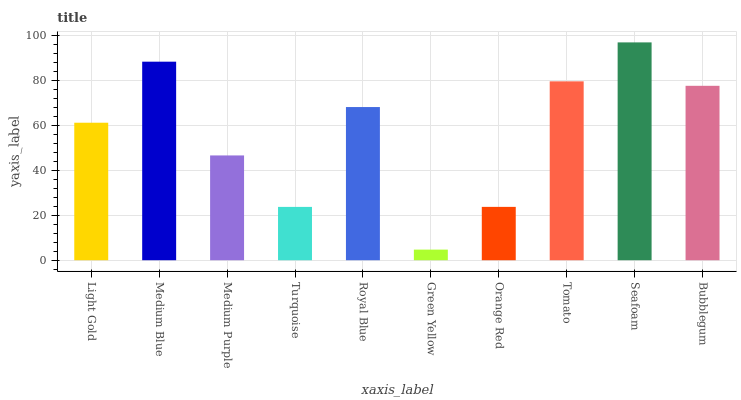Is Green Yellow the minimum?
Answer yes or no. Yes. Is Seafoam the maximum?
Answer yes or no. Yes. Is Medium Blue the minimum?
Answer yes or no. No. Is Medium Blue the maximum?
Answer yes or no. No. Is Medium Blue greater than Light Gold?
Answer yes or no. Yes. Is Light Gold less than Medium Blue?
Answer yes or no. Yes. Is Light Gold greater than Medium Blue?
Answer yes or no. No. Is Medium Blue less than Light Gold?
Answer yes or no. No. Is Royal Blue the high median?
Answer yes or no. Yes. Is Light Gold the low median?
Answer yes or no. Yes. Is Medium Purple the high median?
Answer yes or no. No. Is Green Yellow the low median?
Answer yes or no. No. 